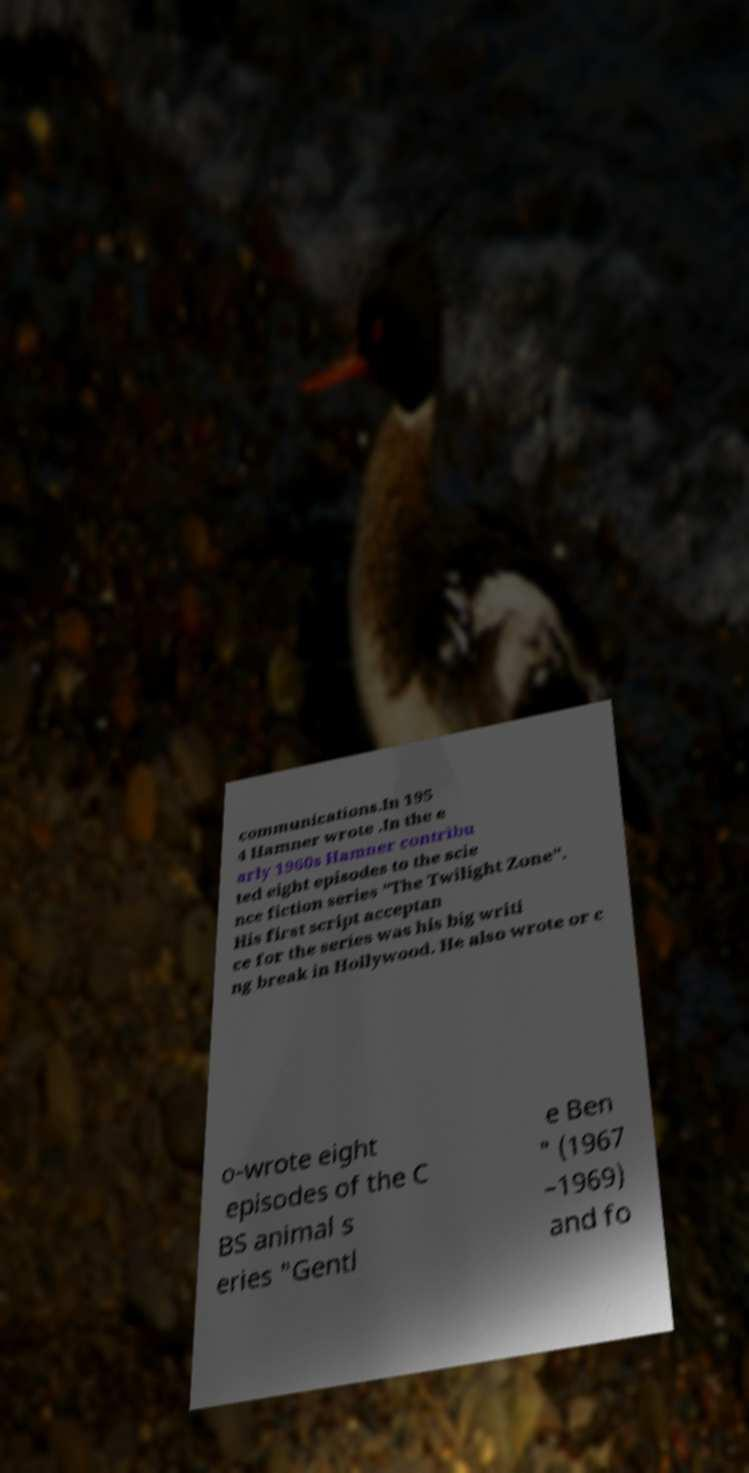Could you extract and type out the text from this image? communications.In 195 4 Hamner wrote .In the e arly 1960s Hamner contribu ted eight episodes to the scie nce fiction series "The Twilight Zone". His first script acceptan ce for the series was his big writi ng break in Hollywood. He also wrote or c o-wrote eight episodes of the C BS animal s eries "Gentl e Ben " (1967 –1969) and fo 